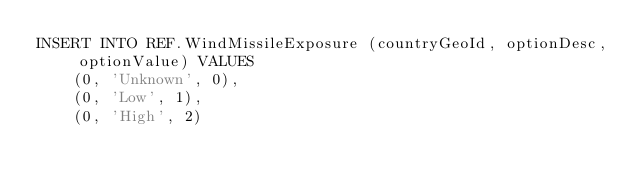<code> <loc_0><loc_0><loc_500><loc_500><_SQL_>INSERT INTO REF.WindMissileExposure (countryGeoId, optionDesc, optionValue) VALUES
    (0, 'Unknown', 0),
    (0, 'Low', 1),
    (0, 'High', 2)</code> 